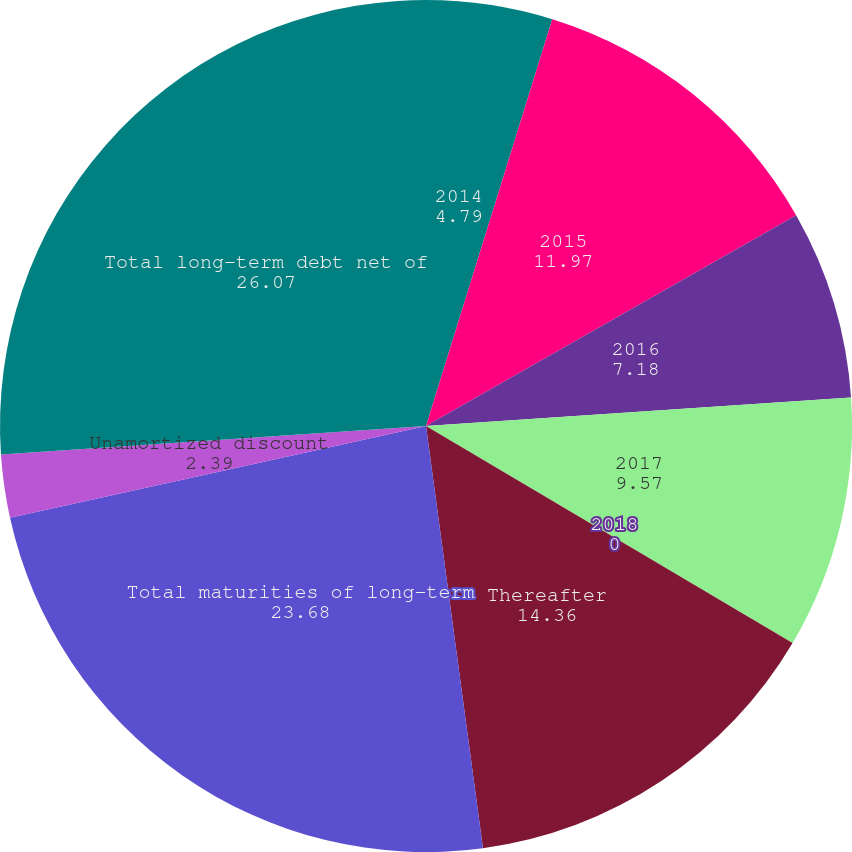<chart> <loc_0><loc_0><loc_500><loc_500><pie_chart><fcel>2014<fcel>2015<fcel>2016<fcel>2017<fcel>2018<fcel>Thereafter<fcel>Total maturities of long-term<fcel>Unamortized discount<fcel>Total long-term debt net of<nl><fcel>4.79%<fcel>11.97%<fcel>7.18%<fcel>9.57%<fcel>0.0%<fcel>14.36%<fcel>23.68%<fcel>2.39%<fcel>26.07%<nl></chart> 